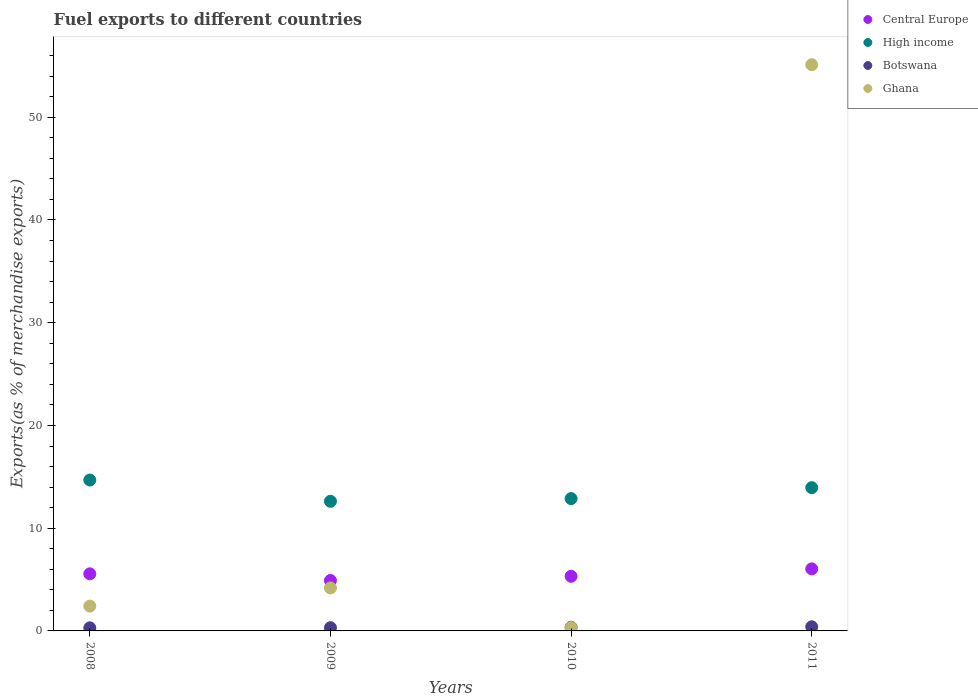Is the number of dotlines equal to the number of legend labels?
Your answer should be very brief. Yes. What is the percentage of exports to different countries in Central Europe in 2010?
Your answer should be compact. 5.32. Across all years, what is the maximum percentage of exports to different countries in Botswana?
Make the answer very short. 0.4. Across all years, what is the minimum percentage of exports to different countries in Central Europe?
Provide a succinct answer. 4.91. What is the total percentage of exports to different countries in Ghana in the graph?
Give a very brief answer. 62.03. What is the difference between the percentage of exports to different countries in Central Europe in 2009 and that in 2010?
Your response must be concise. -0.41. What is the difference between the percentage of exports to different countries in High income in 2010 and the percentage of exports to different countries in Ghana in 2008?
Give a very brief answer. 10.47. What is the average percentage of exports to different countries in Ghana per year?
Make the answer very short. 15.51. In the year 2010, what is the difference between the percentage of exports to different countries in Central Europe and percentage of exports to different countries in Botswana?
Provide a short and direct response. 4.96. What is the ratio of the percentage of exports to different countries in Botswana in 2009 to that in 2010?
Make the answer very short. 0.88. Is the percentage of exports to different countries in Botswana in 2009 less than that in 2010?
Your response must be concise. Yes. What is the difference between the highest and the second highest percentage of exports to different countries in Ghana?
Offer a terse response. 50.93. What is the difference between the highest and the lowest percentage of exports to different countries in Central Europe?
Provide a succinct answer. 1.13. Is it the case that in every year, the sum of the percentage of exports to different countries in Central Europe and percentage of exports to different countries in Ghana  is greater than the sum of percentage of exports to different countries in Botswana and percentage of exports to different countries in High income?
Your answer should be very brief. Yes. Is it the case that in every year, the sum of the percentage of exports to different countries in High income and percentage of exports to different countries in Botswana  is greater than the percentage of exports to different countries in Central Europe?
Provide a short and direct response. Yes. How many dotlines are there?
Give a very brief answer. 4. What is the difference between two consecutive major ticks on the Y-axis?
Provide a succinct answer. 10. Are the values on the major ticks of Y-axis written in scientific E-notation?
Your answer should be compact. No. Does the graph contain any zero values?
Your response must be concise. No. Where does the legend appear in the graph?
Offer a terse response. Top right. How many legend labels are there?
Your response must be concise. 4. What is the title of the graph?
Offer a very short reply. Fuel exports to different countries. What is the label or title of the Y-axis?
Give a very brief answer. Exports(as % of merchandise exports). What is the Exports(as % of merchandise exports) in Central Europe in 2008?
Provide a short and direct response. 5.56. What is the Exports(as % of merchandise exports) in High income in 2008?
Ensure brevity in your answer.  14.69. What is the Exports(as % of merchandise exports) of Botswana in 2008?
Your response must be concise. 0.3. What is the Exports(as % of merchandise exports) of Ghana in 2008?
Offer a terse response. 2.42. What is the Exports(as % of merchandise exports) in Central Europe in 2009?
Provide a succinct answer. 4.91. What is the Exports(as % of merchandise exports) in High income in 2009?
Your answer should be very brief. 12.62. What is the Exports(as % of merchandise exports) of Botswana in 2009?
Your response must be concise. 0.32. What is the Exports(as % of merchandise exports) in Ghana in 2009?
Your answer should be compact. 4.18. What is the Exports(as % of merchandise exports) of Central Europe in 2010?
Offer a terse response. 5.32. What is the Exports(as % of merchandise exports) of High income in 2010?
Your response must be concise. 12.88. What is the Exports(as % of merchandise exports) of Botswana in 2010?
Give a very brief answer. 0.36. What is the Exports(as % of merchandise exports) of Ghana in 2010?
Provide a short and direct response. 0.32. What is the Exports(as % of merchandise exports) in Central Europe in 2011?
Give a very brief answer. 6.04. What is the Exports(as % of merchandise exports) of High income in 2011?
Ensure brevity in your answer.  13.94. What is the Exports(as % of merchandise exports) of Botswana in 2011?
Make the answer very short. 0.4. What is the Exports(as % of merchandise exports) of Ghana in 2011?
Your answer should be compact. 55.11. Across all years, what is the maximum Exports(as % of merchandise exports) in Central Europe?
Your answer should be compact. 6.04. Across all years, what is the maximum Exports(as % of merchandise exports) in High income?
Offer a very short reply. 14.69. Across all years, what is the maximum Exports(as % of merchandise exports) in Botswana?
Make the answer very short. 0.4. Across all years, what is the maximum Exports(as % of merchandise exports) in Ghana?
Your response must be concise. 55.11. Across all years, what is the minimum Exports(as % of merchandise exports) of Central Europe?
Keep it short and to the point. 4.91. Across all years, what is the minimum Exports(as % of merchandise exports) in High income?
Keep it short and to the point. 12.62. Across all years, what is the minimum Exports(as % of merchandise exports) of Botswana?
Your response must be concise. 0.3. Across all years, what is the minimum Exports(as % of merchandise exports) of Ghana?
Offer a terse response. 0.32. What is the total Exports(as % of merchandise exports) of Central Europe in the graph?
Your answer should be compact. 21.83. What is the total Exports(as % of merchandise exports) in High income in the graph?
Make the answer very short. 54.13. What is the total Exports(as % of merchandise exports) of Botswana in the graph?
Offer a terse response. 1.38. What is the total Exports(as % of merchandise exports) of Ghana in the graph?
Keep it short and to the point. 62.03. What is the difference between the Exports(as % of merchandise exports) in Central Europe in 2008 and that in 2009?
Provide a succinct answer. 0.65. What is the difference between the Exports(as % of merchandise exports) in High income in 2008 and that in 2009?
Your response must be concise. 2.07. What is the difference between the Exports(as % of merchandise exports) of Botswana in 2008 and that in 2009?
Make the answer very short. -0.02. What is the difference between the Exports(as % of merchandise exports) of Ghana in 2008 and that in 2009?
Your response must be concise. -1.77. What is the difference between the Exports(as % of merchandise exports) in Central Europe in 2008 and that in 2010?
Ensure brevity in your answer.  0.24. What is the difference between the Exports(as % of merchandise exports) of High income in 2008 and that in 2010?
Your response must be concise. 1.81. What is the difference between the Exports(as % of merchandise exports) of Botswana in 2008 and that in 2010?
Your response must be concise. -0.06. What is the difference between the Exports(as % of merchandise exports) of Ghana in 2008 and that in 2010?
Your answer should be compact. 2.09. What is the difference between the Exports(as % of merchandise exports) of Central Europe in 2008 and that in 2011?
Give a very brief answer. -0.48. What is the difference between the Exports(as % of merchandise exports) of High income in 2008 and that in 2011?
Make the answer very short. 0.74. What is the difference between the Exports(as % of merchandise exports) in Botswana in 2008 and that in 2011?
Keep it short and to the point. -0.1. What is the difference between the Exports(as % of merchandise exports) of Ghana in 2008 and that in 2011?
Provide a succinct answer. -52.7. What is the difference between the Exports(as % of merchandise exports) of Central Europe in 2009 and that in 2010?
Offer a very short reply. -0.41. What is the difference between the Exports(as % of merchandise exports) in High income in 2009 and that in 2010?
Provide a succinct answer. -0.26. What is the difference between the Exports(as % of merchandise exports) in Botswana in 2009 and that in 2010?
Your answer should be very brief. -0.04. What is the difference between the Exports(as % of merchandise exports) of Ghana in 2009 and that in 2010?
Your answer should be compact. 3.86. What is the difference between the Exports(as % of merchandise exports) of Central Europe in 2009 and that in 2011?
Offer a terse response. -1.13. What is the difference between the Exports(as % of merchandise exports) in High income in 2009 and that in 2011?
Offer a terse response. -1.33. What is the difference between the Exports(as % of merchandise exports) of Botswana in 2009 and that in 2011?
Provide a succinct answer. -0.09. What is the difference between the Exports(as % of merchandise exports) of Ghana in 2009 and that in 2011?
Make the answer very short. -50.93. What is the difference between the Exports(as % of merchandise exports) in Central Europe in 2010 and that in 2011?
Offer a very short reply. -0.72. What is the difference between the Exports(as % of merchandise exports) of High income in 2010 and that in 2011?
Offer a very short reply. -1.06. What is the difference between the Exports(as % of merchandise exports) in Botswana in 2010 and that in 2011?
Your answer should be compact. -0.05. What is the difference between the Exports(as % of merchandise exports) in Ghana in 2010 and that in 2011?
Make the answer very short. -54.79. What is the difference between the Exports(as % of merchandise exports) in Central Europe in 2008 and the Exports(as % of merchandise exports) in High income in 2009?
Ensure brevity in your answer.  -7.06. What is the difference between the Exports(as % of merchandise exports) of Central Europe in 2008 and the Exports(as % of merchandise exports) of Botswana in 2009?
Provide a succinct answer. 5.24. What is the difference between the Exports(as % of merchandise exports) in Central Europe in 2008 and the Exports(as % of merchandise exports) in Ghana in 2009?
Ensure brevity in your answer.  1.38. What is the difference between the Exports(as % of merchandise exports) of High income in 2008 and the Exports(as % of merchandise exports) of Botswana in 2009?
Provide a succinct answer. 14.37. What is the difference between the Exports(as % of merchandise exports) in High income in 2008 and the Exports(as % of merchandise exports) in Ghana in 2009?
Offer a very short reply. 10.5. What is the difference between the Exports(as % of merchandise exports) of Botswana in 2008 and the Exports(as % of merchandise exports) of Ghana in 2009?
Your response must be concise. -3.88. What is the difference between the Exports(as % of merchandise exports) of Central Europe in 2008 and the Exports(as % of merchandise exports) of High income in 2010?
Your answer should be very brief. -7.32. What is the difference between the Exports(as % of merchandise exports) of Central Europe in 2008 and the Exports(as % of merchandise exports) of Botswana in 2010?
Your answer should be compact. 5.2. What is the difference between the Exports(as % of merchandise exports) in Central Europe in 2008 and the Exports(as % of merchandise exports) in Ghana in 2010?
Your response must be concise. 5.23. What is the difference between the Exports(as % of merchandise exports) in High income in 2008 and the Exports(as % of merchandise exports) in Botswana in 2010?
Provide a succinct answer. 14.33. What is the difference between the Exports(as % of merchandise exports) in High income in 2008 and the Exports(as % of merchandise exports) in Ghana in 2010?
Keep it short and to the point. 14.36. What is the difference between the Exports(as % of merchandise exports) in Botswana in 2008 and the Exports(as % of merchandise exports) in Ghana in 2010?
Keep it short and to the point. -0.02. What is the difference between the Exports(as % of merchandise exports) in Central Europe in 2008 and the Exports(as % of merchandise exports) in High income in 2011?
Give a very brief answer. -8.39. What is the difference between the Exports(as % of merchandise exports) of Central Europe in 2008 and the Exports(as % of merchandise exports) of Botswana in 2011?
Give a very brief answer. 5.15. What is the difference between the Exports(as % of merchandise exports) of Central Europe in 2008 and the Exports(as % of merchandise exports) of Ghana in 2011?
Offer a very short reply. -49.55. What is the difference between the Exports(as % of merchandise exports) in High income in 2008 and the Exports(as % of merchandise exports) in Botswana in 2011?
Your answer should be compact. 14.28. What is the difference between the Exports(as % of merchandise exports) of High income in 2008 and the Exports(as % of merchandise exports) of Ghana in 2011?
Your answer should be very brief. -40.42. What is the difference between the Exports(as % of merchandise exports) of Botswana in 2008 and the Exports(as % of merchandise exports) of Ghana in 2011?
Your answer should be very brief. -54.81. What is the difference between the Exports(as % of merchandise exports) of Central Europe in 2009 and the Exports(as % of merchandise exports) of High income in 2010?
Make the answer very short. -7.97. What is the difference between the Exports(as % of merchandise exports) of Central Europe in 2009 and the Exports(as % of merchandise exports) of Botswana in 2010?
Provide a succinct answer. 4.55. What is the difference between the Exports(as % of merchandise exports) of Central Europe in 2009 and the Exports(as % of merchandise exports) of Ghana in 2010?
Your response must be concise. 4.59. What is the difference between the Exports(as % of merchandise exports) of High income in 2009 and the Exports(as % of merchandise exports) of Botswana in 2010?
Your answer should be very brief. 12.26. What is the difference between the Exports(as % of merchandise exports) of High income in 2009 and the Exports(as % of merchandise exports) of Ghana in 2010?
Offer a terse response. 12.29. What is the difference between the Exports(as % of merchandise exports) of Botswana in 2009 and the Exports(as % of merchandise exports) of Ghana in 2010?
Give a very brief answer. -0.01. What is the difference between the Exports(as % of merchandise exports) of Central Europe in 2009 and the Exports(as % of merchandise exports) of High income in 2011?
Offer a very short reply. -9.04. What is the difference between the Exports(as % of merchandise exports) of Central Europe in 2009 and the Exports(as % of merchandise exports) of Botswana in 2011?
Ensure brevity in your answer.  4.5. What is the difference between the Exports(as % of merchandise exports) in Central Europe in 2009 and the Exports(as % of merchandise exports) in Ghana in 2011?
Give a very brief answer. -50.2. What is the difference between the Exports(as % of merchandise exports) in High income in 2009 and the Exports(as % of merchandise exports) in Botswana in 2011?
Your answer should be very brief. 12.21. What is the difference between the Exports(as % of merchandise exports) in High income in 2009 and the Exports(as % of merchandise exports) in Ghana in 2011?
Offer a terse response. -42.49. What is the difference between the Exports(as % of merchandise exports) in Botswana in 2009 and the Exports(as % of merchandise exports) in Ghana in 2011?
Provide a short and direct response. -54.8. What is the difference between the Exports(as % of merchandise exports) of Central Europe in 2010 and the Exports(as % of merchandise exports) of High income in 2011?
Your answer should be very brief. -8.63. What is the difference between the Exports(as % of merchandise exports) of Central Europe in 2010 and the Exports(as % of merchandise exports) of Botswana in 2011?
Your response must be concise. 4.91. What is the difference between the Exports(as % of merchandise exports) in Central Europe in 2010 and the Exports(as % of merchandise exports) in Ghana in 2011?
Your answer should be very brief. -49.79. What is the difference between the Exports(as % of merchandise exports) in High income in 2010 and the Exports(as % of merchandise exports) in Botswana in 2011?
Offer a terse response. 12.48. What is the difference between the Exports(as % of merchandise exports) of High income in 2010 and the Exports(as % of merchandise exports) of Ghana in 2011?
Provide a succinct answer. -42.23. What is the difference between the Exports(as % of merchandise exports) in Botswana in 2010 and the Exports(as % of merchandise exports) in Ghana in 2011?
Offer a very short reply. -54.76. What is the average Exports(as % of merchandise exports) in Central Europe per year?
Provide a succinct answer. 5.46. What is the average Exports(as % of merchandise exports) in High income per year?
Provide a succinct answer. 13.53. What is the average Exports(as % of merchandise exports) in Botswana per year?
Provide a short and direct response. 0.34. What is the average Exports(as % of merchandise exports) of Ghana per year?
Provide a short and direct response. 15.51. In the year 2008, what is the difference between the Exports(as % of merchandise exports) in Central Europe and Exports(as % of merchandise exports) in High income?
Offer a very short reply. -9.13. In the year 2008, what is the difference between the Exports(as % of merchandise exports) in Central Europe and Exports(as % of merchandise exports) in Botswana?
Your answer should be very brief. 5.26. In the year 2008, what is the difference between the Exports(as % of merchandise exports) in Central Europe and Exports(as % of merchandise exports) in Ghana?
Provide a short and direct response. 3.14. In the year 2008, what is the difference between the Exports(as % of merchandise exports) in High income and Exports(as % of merchandise exports) in Botswana?
Keep it short and to the point. 14.39. In the year 2008, what is the difference between the Exports(as % of merchandise exports) in High income and Exports(as % of merchandise exports) in Ghana?
Provide a short and direct response. 12.27. In the year 2008, what is the difference between the Exports(as % of merchandise exports) of Botswana and Exports(as % of merchandise exports) of Ghana?
Ensure brevity in your answer.  -2.12. In the year 2009, what is the difference between the Exports(as % of merchandise exports) in Central Europe and Exports(as % of merchandise exports) in High income?
Your answer should be very brief. -7.71. In the year 2009, what is the difference between the Exports(as % of merchandise exports) of Central Europe and Exports(as % of merchandise exports) of Botswana?
Your answer should be very brief. 4.59. In the year 2009, what is the difference between the Exports(as % of merchandise exports) of Central Europe and Exports(as % of merchandise exports) of Ghana?
Offer a terse response. 0.73. In the year 2009, what is the difference between the Exports(as % of merchandise exports) of High income and Exports(as % of merchandise exports) of Botswana?
Offer a very short reply. 12.3. In the year 2009, what is the difference between the Exports(as % of merchandise exports) of High income and Exports(as % of merchandise exports) of Ghana?
Make the answer very short. 8.43. In the year 2009, what is the difference between the Exports(as % of merchandise exports) of Botswana and Exports(as % of merchandise exports) of Ghana?
Your answer should be compact. -3.87. In the year 2010, what is the difference between the Exports(as % of merchandise exports) of Central Europe and Exports(as % of merchandise exports) of High income?
Keep it short and to the point. -7.56. In the year 2010, what is the difference between the Exports(as % of merchandise exports) of Central Europe and Exports(as % of merchandise exports) of Botswana?
Your answer should be compact. 4.96. In the year 2010, what is the difference between the Exports(as % of merchandise exports) in Central Europe and Exports(as % of merchandise exports) in Ghana?
Your answer should be very brief. 4.99. In the year 2010, what is the difference between the Exports(as % of merchandise exports) in High income and Exports(as % of merchandise exports) in Botswana?
Offer a terse response. 12.52. In the year 2010, what is the difference between the Exports(as % of merchandise exports) of High income and Exports(as % of merchandise exports) of Ghana?
Make the answer very short. 12.56. In the year 2010, what is the difference between the Exports(as % of merchandise exports) of Botswana and Exports(as % of merchandise exports) of Ghana?
Provide a succinct answer. 0.03. In the year 2011, what is the difference between the Exports(as % of merchandise exports) of Central Europe and Exports(as % of merchandise exports) of High income?
Make the answer very short. -7.9. In the year 2011, what is the difference between the Exports(as % of merchandise exports) of Central Europe and Exports(as % of merchandise exports) of Botswana?
Your answer should be compact. 5.64. In the year 2011, what is the difference between the Exports(as % of merchandise exports) of Central Europe and Exports(as % of merchandise exports) of Ghana?
Give a very brief answer. -49.07. In the year 2011, what is the difference between the Exports(as % of merchandise exports) of High income and Exports(as % of merchandise exports) of Botswana?
Your answer should be compact. 13.54. In the year 2011, what is the difference between the Exports(as % of merchandise exports) in High income and Exports(as % of merchandise exports) in Ghana?
Keep it short and to the point. -41.17. In the year 2011, what is the difference between the Exports(as % of merchandise exports) of Botswana and Exports(as % of merchandise exports) of Ghana?
Keep it short and to the point. -54.71. What is the ratio of the Exports(as % of merchandise exports) in Central Europe in 2008 to that in 2009?
Ensure brevity in your answer.  1.13. What is the ratio of the Exports(as % of merchandise exports) of High income in 2008 to that in 2009?
Offer a very short reply. 1.16. What is the ratio of the Exports(as % of merchandise exports) in Botswana in 2008 to that in 2009?
Your answer should be very brief. 0.95. What is the ratio of the Exports(as % of merchandise exports) of Ghana in 2008 to that in 2009?
Offer a terse response. 0.58. What is the ratio of the Exports(as % of merchandise exports) of Central Europe in 2008 to that in 2010?
Your response must be concise. 1.05. What is the ratio of the Exports(as % of merchandise exports) in High income in 2008 to that in 2010?
Offer a terse response. 1.14. What is the ratio of the Exports(as % of merchandise exports) in Botswana in 2008 to that in 2010?
Provide a succinct answer. 0.84. What is the ratio of the Exports(as % of merchandise exports) of Ghana in 2008 to that in 2010?
Offer a terse response. 7.47. What is the ratio of the Exports(as % of merchandise exports) of Central Europe in 2008 to that in 2011?
Offer a very short reply. 0.92. What is the ratio of the Exports(as % of merchandise exports) in High income in 2008 to that in 2011?
Your response must be concise. 1.05. What is the ratio of the Exports(as % of merchandise exports) in Botswana in 2008 to that in 2011?
Keep it short and to the point. 0.74. What is the ratio of the Exports(as % of merchandise exports) in Ghana in 2008 to that in 2011?
Your answer should be very brief. 0.04. What is the ratio of the Exports(as % of merchandise exports) in Central Europe in 2009 to that in 2010?
Provide a succinct answer. 0.92. What is the ratio of the Exports(as % of merchandise exports) of High income in 2009 to that in 2010?
Give a very brief answer. 0.98. What is the ratio of the Exports(as % of merchandise exports) in Botswana in 2009 to that in 2010?
Keep it short and to the point. 0.88. What is the ratio of the Exports(as % of merchandise exports) of Ghana in 2009 to that in 2010?
Your response must be concise. 12.93. What is the ratio of the Exports(as % of merchandise exports) in Central Europe in 2009 to that in 2011?
Offer a terse response. 0.81. What is the ratio of the Exports(as % of merchandise exports) of High income in 2009 to that in 2011?
Offer a terse response. 0.9. What is the ratio of the Exports(as % of merchandise exports) of Botswana in 2009 to that in 2011?
Provide a short and direct response. 0.78. What is the ratio of the Exports(as % of merchandise exports) in Ghana in 2009 to that in 2011?
Keep it short and to the point. 0.08. What is the ratio of the Exports(as % of merchandise exports) in Central Europe in 2010 to that in 2011?
Make the answer very short. 0.88. What is the ratio of the Exports(as % of merchandise exports) in High income in 2010 to that in 2011?
Give a very brief answer. 0.92. What is the ratio of the Exports(as % of merchandise exports) in Botswana in 2010 to that in 2011?
Keep it short and to the point. 0.88. What is the ratio of the Exports(as % of merchandise exports) in Ghana in 2010 to that in 2011?
Ensure brevity in your answer.  0.01. What is the difference between the highest and the second highest Exports(as % of merchandise exports) in Central Europe?
Give a very brief answer. 0.48. What is the difference between the highest and the second highest Exports(as % of merchandise exports) of High income?
Ensure brevity in your answer.  0.74. What is the difference between the highest and the second highest Exports(as % of merchandise exports) of Botswana?
Provide a short and direct response. 0.05. What is the difference between the highest and the second highest Exports(as % of merchandise exports) in Ghana?
Give a very brief answer. 50.93. What is the difference between the highest and the lowest Exports(as % of merchandise exports) in Central Europe?
Offer a very short reply. 1.13. What is the difference between the highest and the lowest Exports(as % of merchandise exports) in High income?
Offer a very short reply. 2.07. What is the difference between the highest and the lowest Exports(as % of merchandise exports) in Botswana?
Offer a terse response. 0.1. What is the difference between the highest and the lowest Exports(as % of merchandise exports) in Ghana?
Provide a short and direct response. 54.79. 